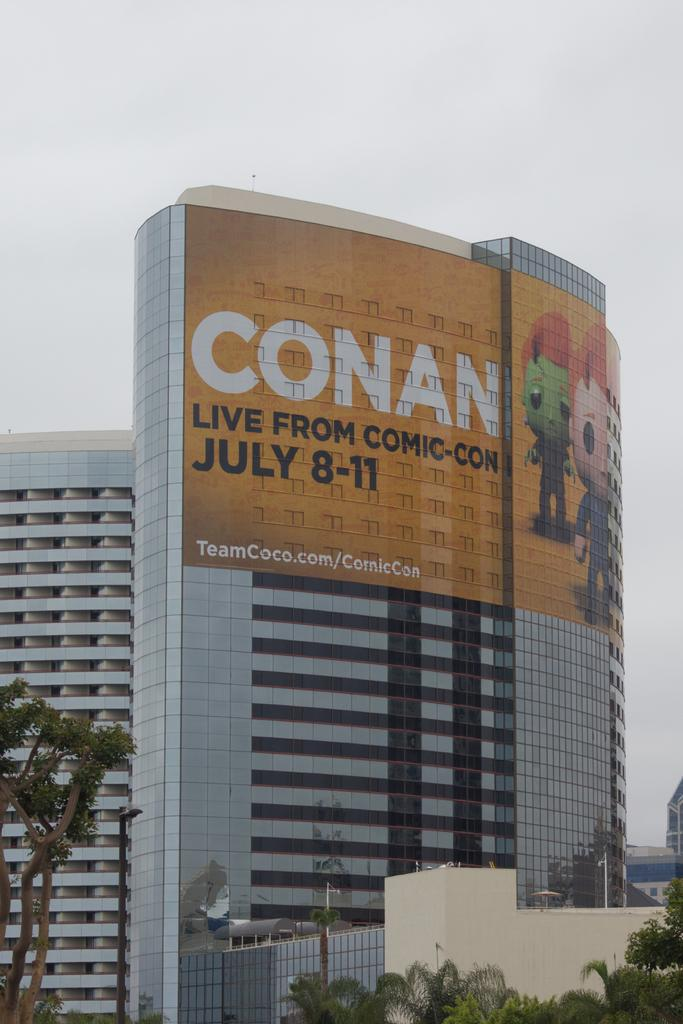What type of structure is present in the image? There is a building in the image. What is hanging or attached to the building? There is a banner in the image. What type of vegetation can be seen in the image? There are trees in the image. What else can be seen in the image besides the building and trees? There are some objects in the image. What is visible in the background of the image? The sky is visible in the background of the image. What type of butter is being used to paint the banner in the image? There is no butter present in the image, and the banner is not being painted. 